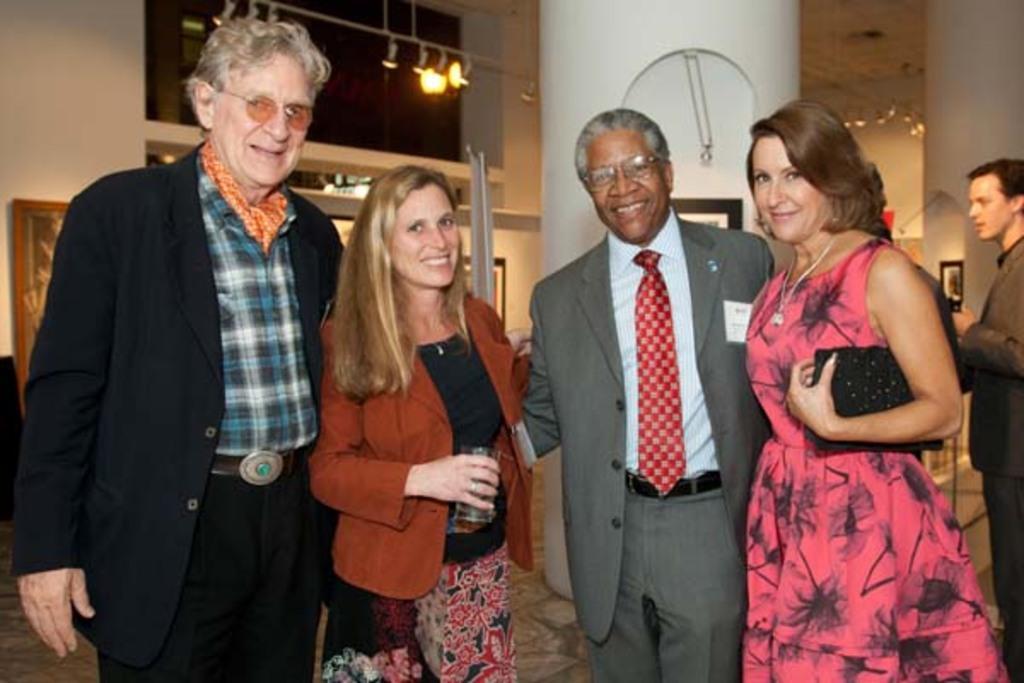Can you describe this image briefly? In this image we can see some people standing and we can also see glass, lights and pole. 